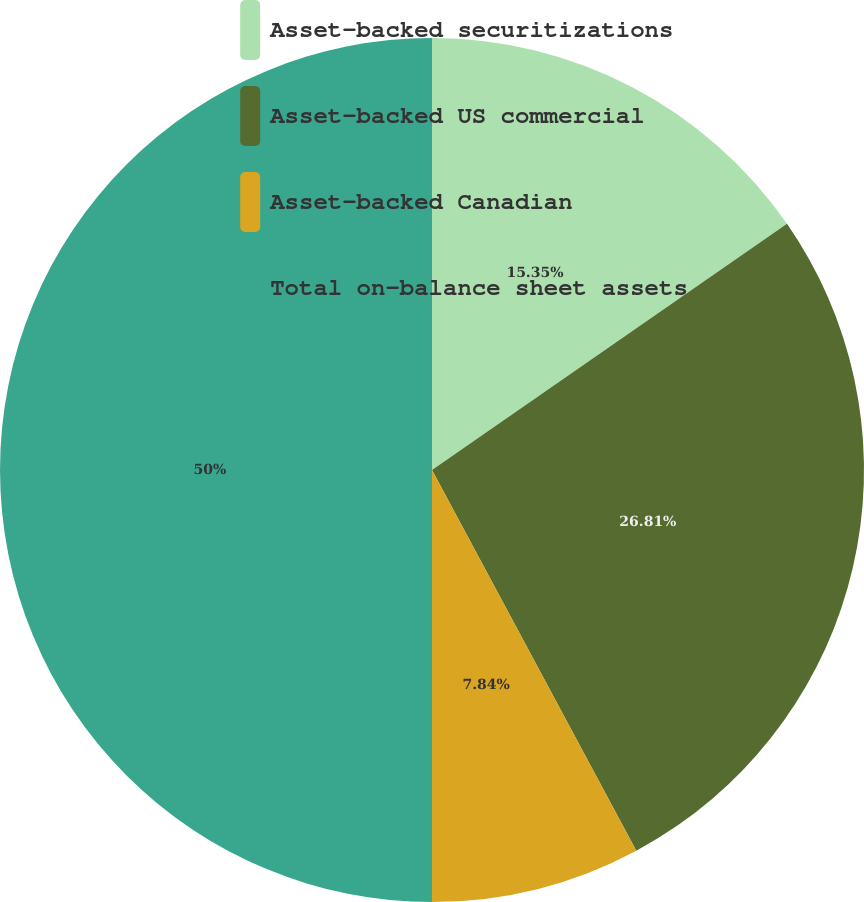Convert chart to OTSL. <chart><loc_0><loc_0><loc_500><loc_500><pie_chart><fcel>Asset-backed securitizations<fcel>Asset-backed US commercial<fcel>Asset-backed Canadian<fcel>Total on-balance sheet assets<nl><fcel>15.35%<fcel>26.81%<fcel>7.84%<fcel>50.0%<nl></chart> 